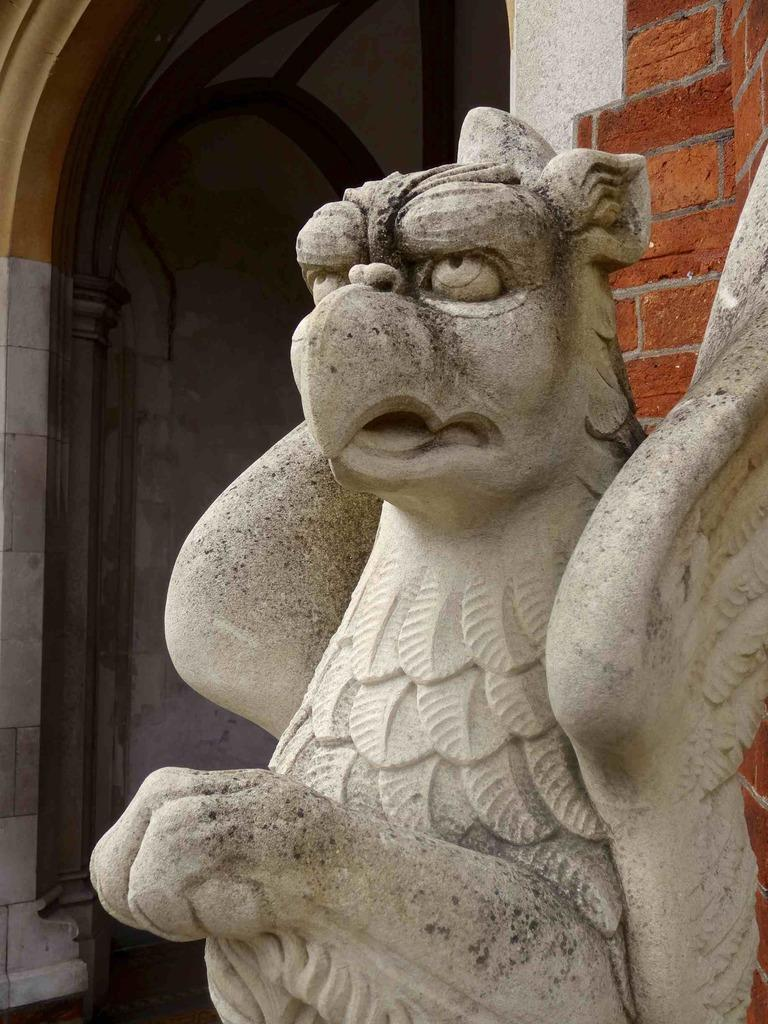What is the main subject in the center of the image? There is a statue in the center of the image. What can be seen in the background of the image? There is a building in the background of the image. What type of pen is the statue holding in the image? There is no pen present in the image; the statue is not holding any object. 